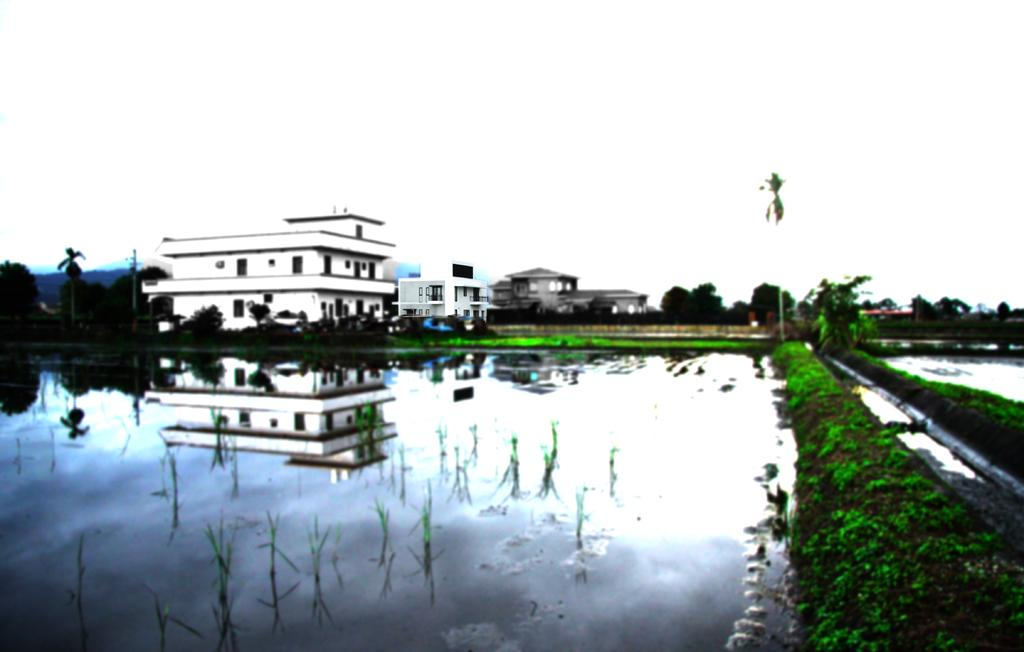What is one of the main elements in the image? There is water in the image. What structures can be seen in the image? There are poles, plants, trees, and buildings in the image. What is the condition of the water in the image? The water has a reflection in it. What can be seen in the background of the image? There is sky visible in the background of the image. What type of insect can be seen crawling on the mother's hand in the image? There is no insect or mother present in the image; it features water, poles, plants, trees, buildings, and a reflection. 